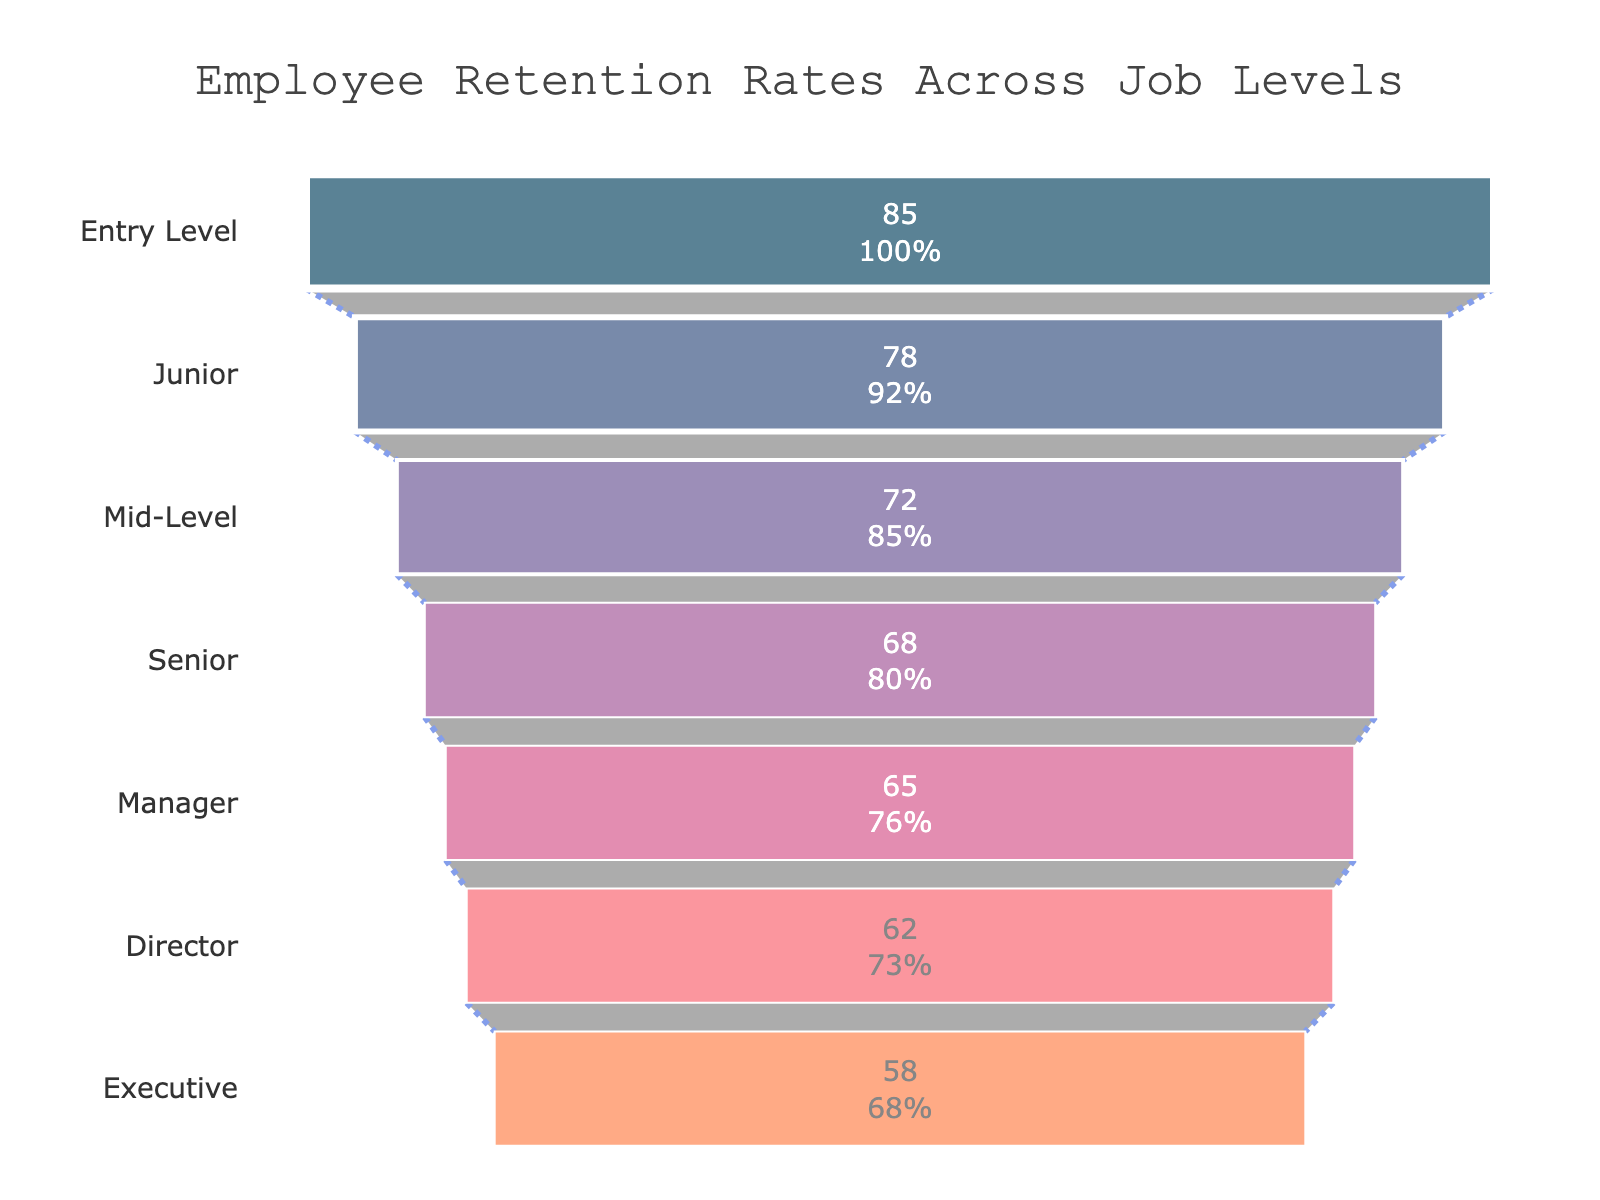What's the title of the chart? The title is located at the top center of the chart. From the visual, the title reads "Employee Retention Rates Across Job Levels".
Answer: Employee Retention Rates Across Job Levels How many job levels are displayed in the chart? The chart displays each job level as a section in the funnel. By counting the sections, we can see there are seven job levels.
Answer: Seven Which job level has the highest retention rate? The highest retention rate is represented by the widest segment at the top of the funnel. The top segment is labeled "Entry Level" with a retention rate of 85%.
Answer: Entry Level Which job level has the lowest retention rate? The lowest retention rate is represented by the narrowest segment at the bottom of the funnel. The bottom segment is labeled "Executive" with a retention rate of 58%.
Answer: Executive What is the retention rate difference between Entry Level and Senior? We compare the retention rates of "Entry Level" (85%) and "Senior" (68%) and subtract the latter from the former: 85% - 68% = 17%.
Answer: 17% What is the average retention rate of all job levels displayed? Sum all the retention rates: 85 + 78 + 72 + 68 + 65 + 62 + 58 = 488. Since there are seven job levels, divide the total sum by 7: 488 / 7 ≈ 69.71.
Answer: 69.71% Is the retention rate for Mid-Level higher or lower than that for Junior? By comparing the segments, "Mid-Level" has a retention rate of 72%, and "Junior" has a rate of 78%. Mid-Level is lower than Junior.
Answer: Lower What percentage of the initial retention rate does the Director level represent? The retention rate of the Entry Level (initial rate) is 85%. The Director level retention rate is 62%. Calculate the percentage: (62 / 85) * 100 ≈ 72.94%.
Answer: 72.94% What is the color of the segment representing the Manager level? Each job level is represented by a different color. The Manager level segment is colored in a shade of pink (corners shaded based on data).
Answer: Pink What is the range of retention rates across all job levels? To find the range, subtract the smallest retention rate from the largest: 85 (Entry Level) - 58 (Executive) = 27.
Answer: 27 